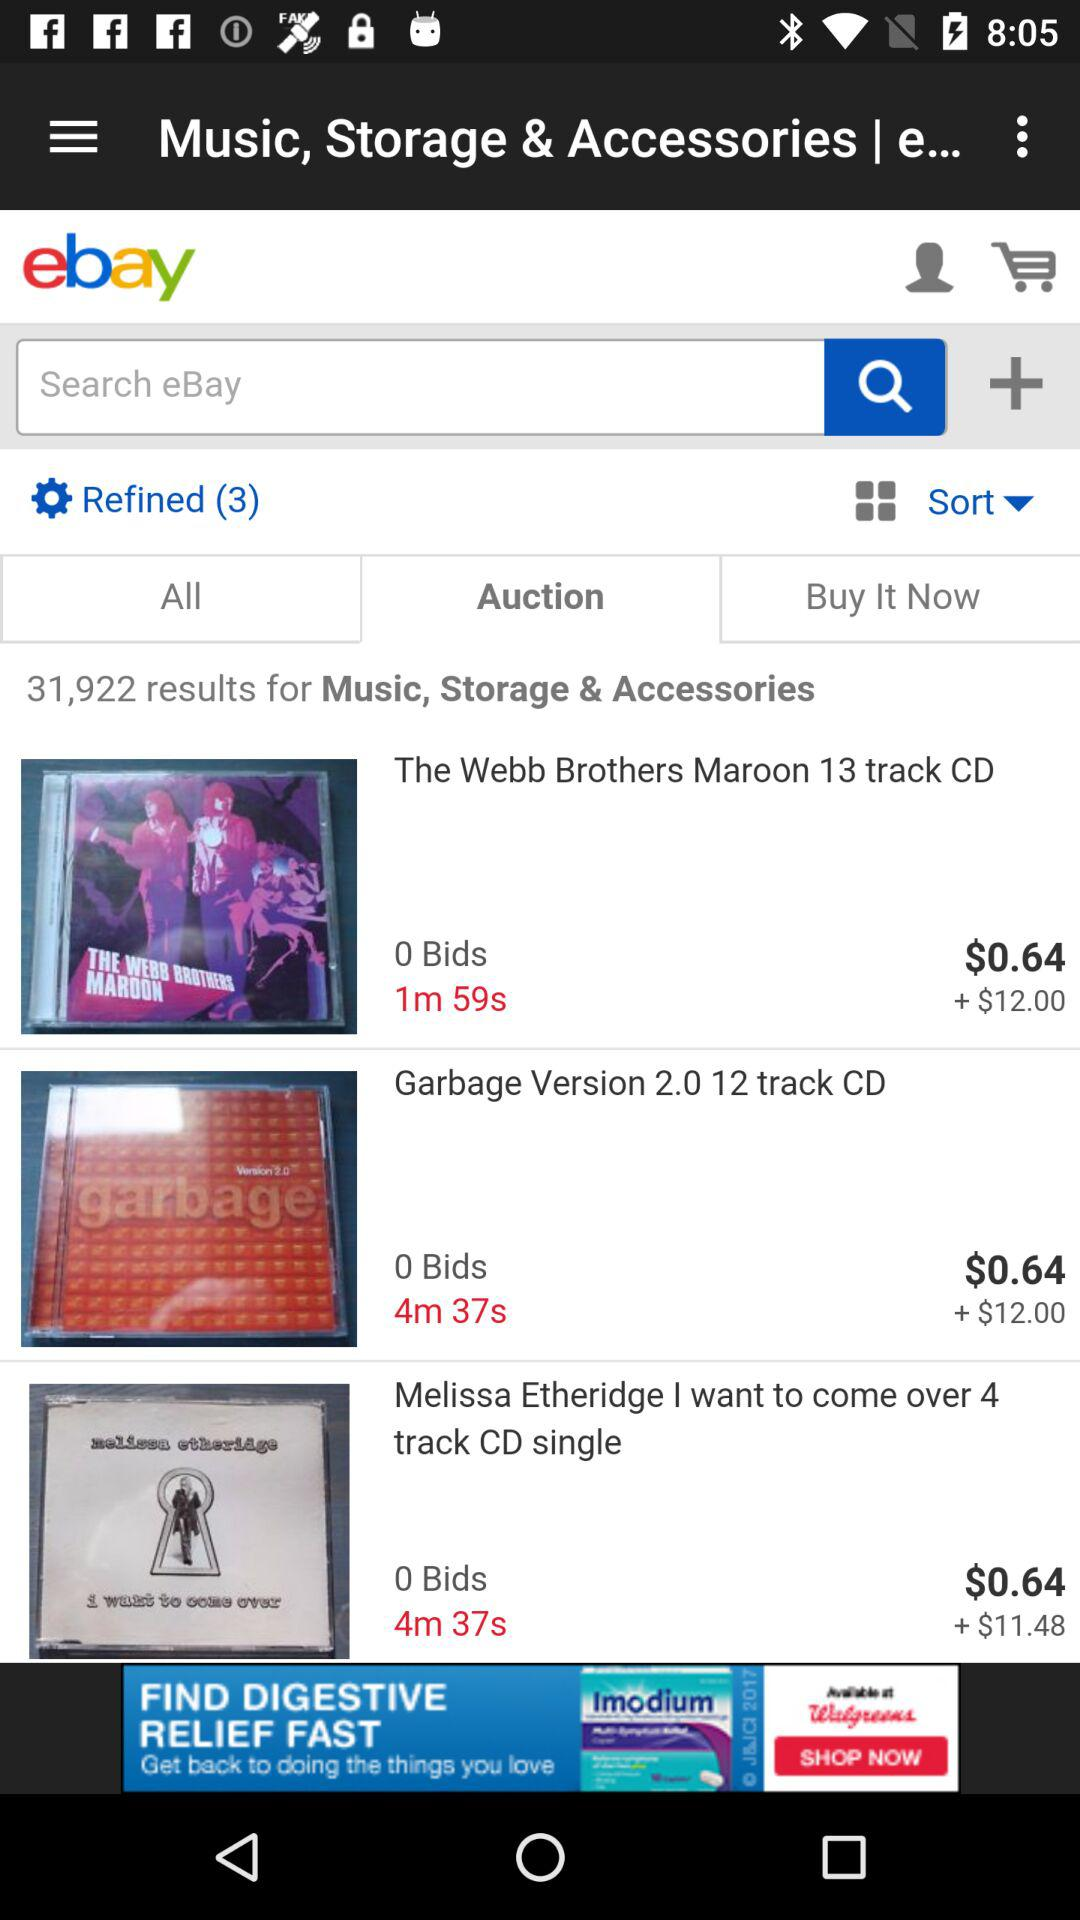What is the remaining time for the "Garbage Version 2.0 12 track CD" auction? The remaining time for the "Garbage Version 2.0 12 track CD" auction is 4 minutes and 37 seconds. 